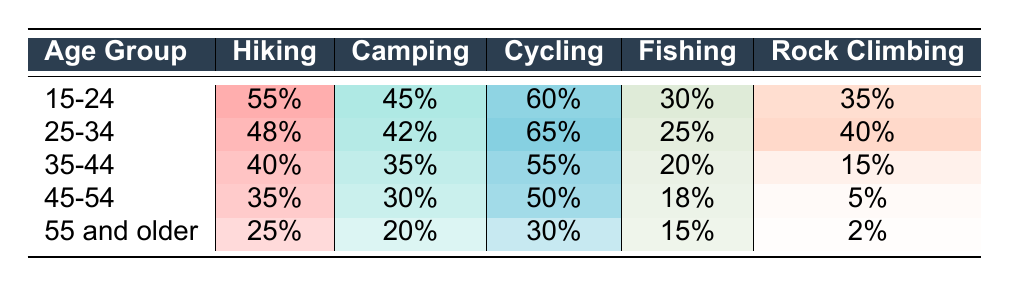What is the hiking participation rate for the 25-34 age group? The table shows that the hiking participation rate for the 25-34 age group is directly listed under that group's row, which indicates a rate of 48%.
Answer: 48% Which age group has the highest cycling participation rate? By comparing the cycling participation percentages across all age groups, the highest rate appears in the 25-34 age group where it is 65%.
Answer: 25-34 Is the fishing participation rate higher for the 35-44 age group than for the 45-54 age group? The fishing participation rate for the 35-44 age group is 20%, while for the 45-54 age group, it is 18%. Since 20% is greater than 18%, the statement is true.
Answer: Yes What is the difference in hiking participation rates between the 15-24 age group and the 55 and older age group? The hiking participation rate for the 15-24 age group is 55%, while for the 55 and older age group it is 25%. The difference is calculated as 55% - 25% = 30%.
Answer: 30% What is the average camping participation rate for all age groups? To calculate the average camping rate, sum the participation rates: 45 + 42 + 35 + 30 + 20 = 172. Then divide by the number of age groups (5): 172 / 5 = 34.4%.
Answer: 34.4% Which activity has the lowest participation rate among the 45-54 age group? Looking at the activities for the 45-54 age group, the rates are 35% (hiking), 30% (camping), 50% (cycling), 18% (fishing), and 5% (rock climbing). The lowest of these is 5%, which corresponds to rock climbing.
Answer: Rock Climbing Is the participation rate for cycling among the 55 and older age group equal to the participation rate for fishing among the 15-24 age group? The cycling participation rate for the 55 and older age group is 30%, and the fishing participation rate for the 15-24 age group is 30% as well. Since both rates are the same, the statement is true.
Answer: Yes Which age group shows the largest percentage of rock climbing participants? By examining the data for rock climbing across age groups, the highest percentage is 40% found in the 25-34 age group.
Answer: 25-34 